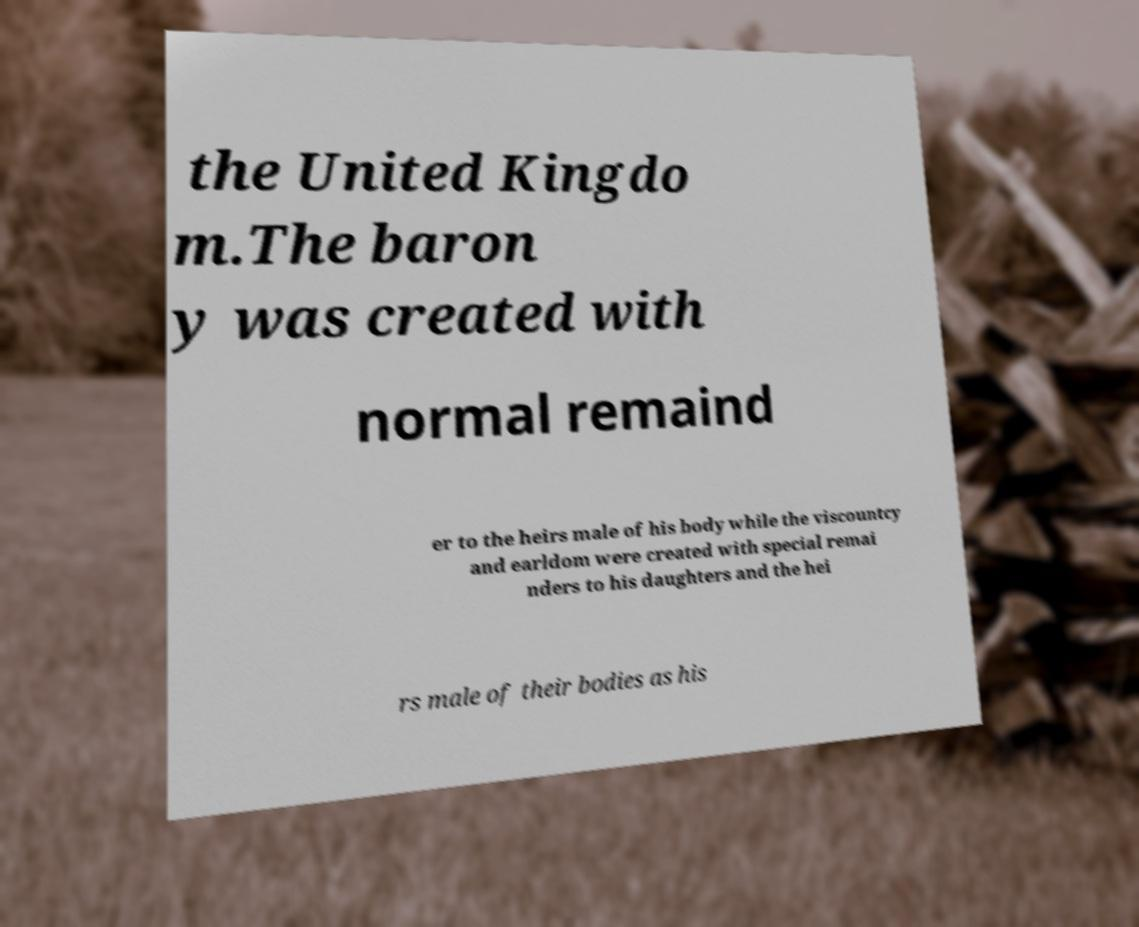Please identify and transcribe the text found in this image. the United Kingdo m.The baron y was created with normal remaind er to the heirs male of his body while the viscountcy and earldom were created with special remai nders to his daughters and the hei rs male of their bodies as his 